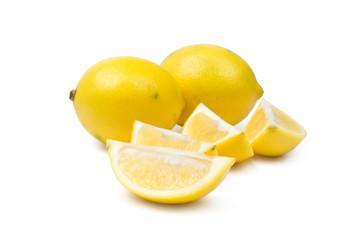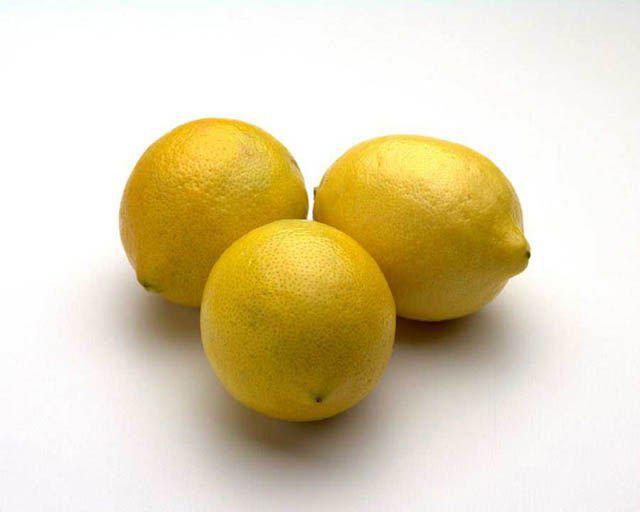The first image is the image on the left, the second image is the image on the right. Analyze the images presented: Is the assertion "In one image, some lemons are cut, in the other, none of the lemons are cut." valid? Answer yes or no. Yes. The first image is the image on the left, the second image is the image on the right. Considering the images on both sides, is "In one image there is a combination of sliced and whole lemons, and in the other image there are three whole lemons" valid? Answer yes or no. Yes. 